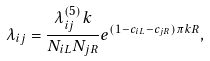<formula> <loc_0><loc_0><loc_500><loc_500>\lambda _ { i j } = \frac { \lambda _ { i j } ^ { ( 5 ) } k } { N _ { i L } N _ { j R } } e ^ { ( 1 - c _ { i L } - c _ { j R } ) \pi k R } ,</formula> 